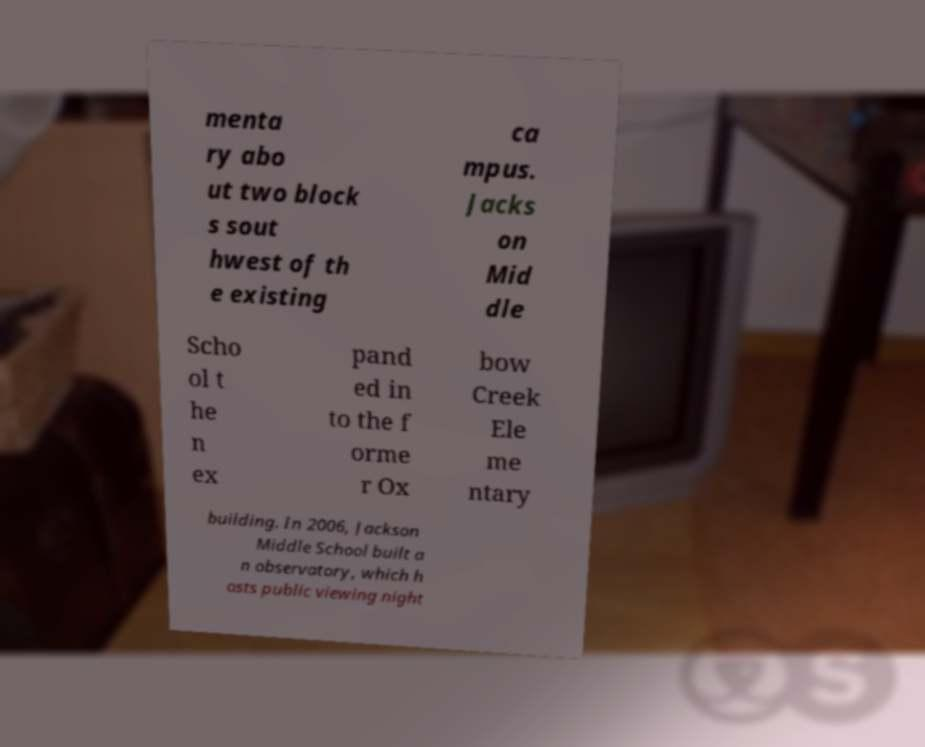For documentation purposes, I need the text within this image transcribed. Could you provide that? menta ry abo ut two block s sout hwest of th e existing ca mpus. Jacks on Mid dle Scho ol t he n ex pand ed in to the f orme r Ox bow Creek Ele me ntary building. In 2006, Jackson Middle School built a n observatory, which h osts public viewing night 